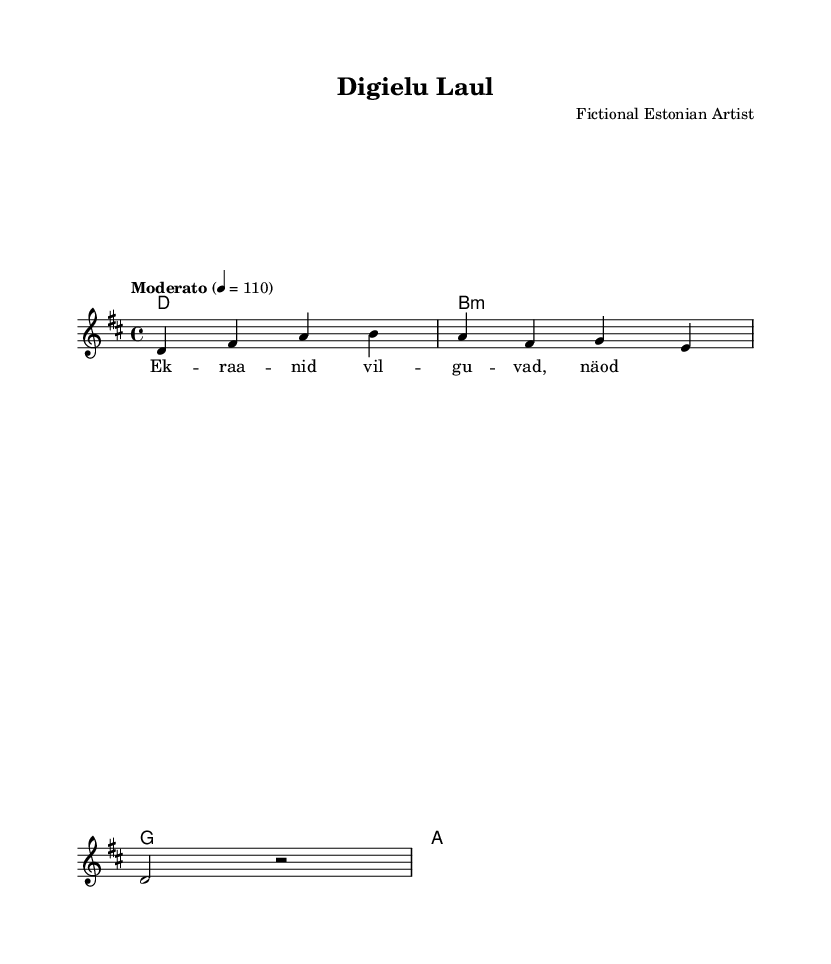What is the key signature of this music? The key signature is D major, which has two sharps (F# and C#). This can be determined by looking at the key signature notation at the beginning of the sheet music.
Answer: D major What is the time signature of this piece? The time signature is 4/4, as indicated at the beginning of the score. This means there are four beats in each measure, and each beat is a quarter note.
Answer: 4/4 What is the tempo marking of the song? The tempo marking is "Moderato," indicating a moderate speed, which is specified along with the metronome marking of 110 beats per minute.
Answer: Moderato How many measures are in the melody? The melody consists of four measures, as you can count the vertical lines indicating the end of each measure throughout the melody part.
Answer: 4 What is the first note of the melody? The first note of the melody is D, which can be seen at the start of the melody section in the sheet music.
Answer: D What chords accompany the melody? The chords accompanying the melody are D, B minor, G, and A, listed sequentially in the chord mode section above the melody. Each chord corresponds to a measure.
Answer: D, B minor, G, A What is the lyrical theme of the song based on the title? The lyrical theme can be inferred to involve digital life, as suggested by the title "Digielu Laul," which translates to "Digital Life Song" in English.
Answer: Digital Life 